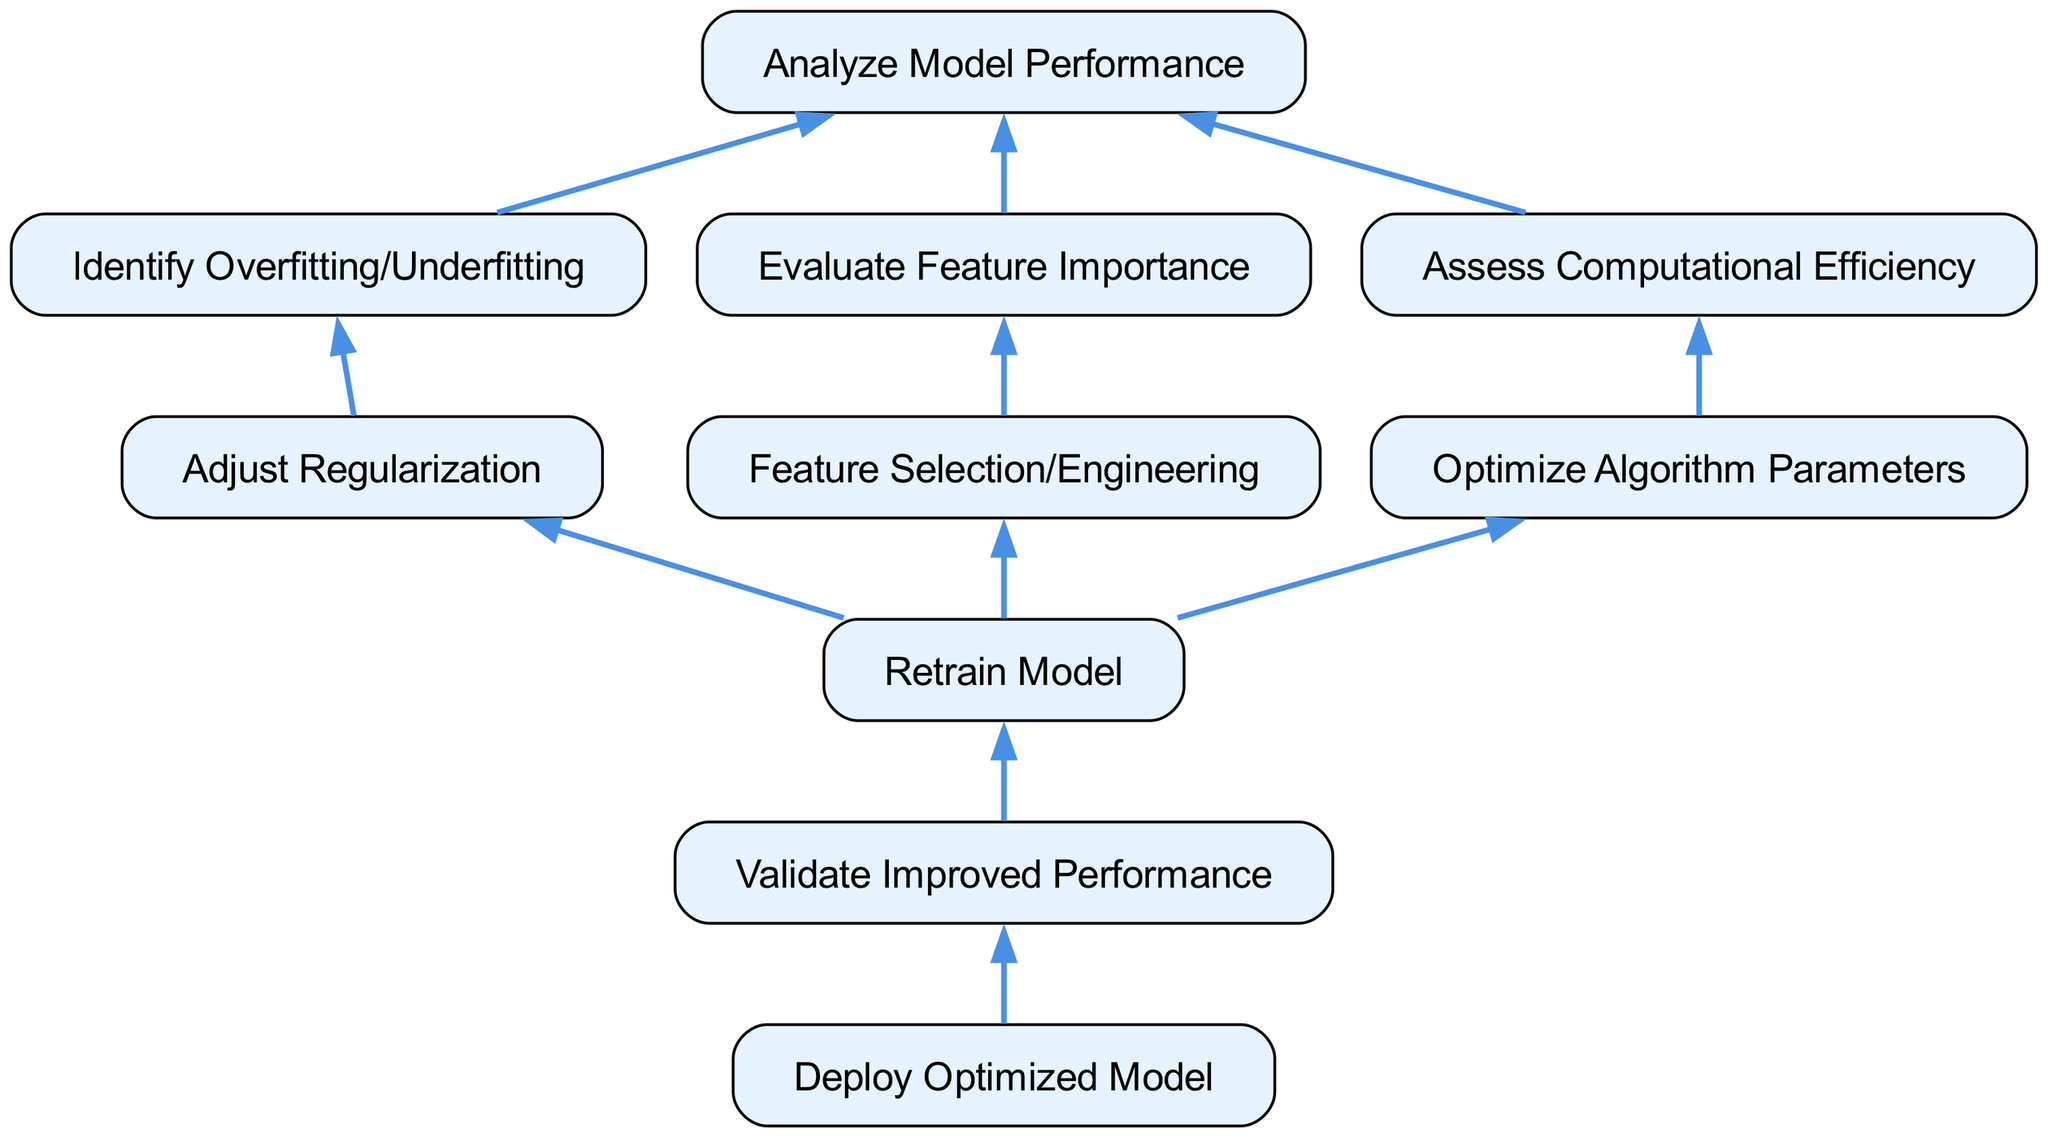What is the final step in the optimization process? The flow chart shows that after "Validate Improved Performance," the next step is "Deploy Optimized Model," which is indicated as the last node.
Answer: Deploy Optimized Model How many main branches are there starting from "Analyze Model Performance"? The diagram indicates three children nodes stemming from "Analyze Model Performance," which are "Identify Overfitting/Underfitting," "Evaluate Feature Importance," and "Assess Computational Efficiency."
Answer: Three What action is taken after "Assess Computational Efficiency"? Following "Assess Computational Efficiency," the flow progresses to "Optimize Algorithm Parameters," which is specifically the next child node for the previous step.
Answer: Optimize Algorithm Parameters Which node leads to "Retrain Model"? The children nodes of "Adjust Regularization," "Feature Selection/Engineering," and "Optimize Algorithm Parameters" all lead into the next step "Retrain Model," as indicated in the diagram's structure.
Answer: Adjust Regularization, Feature Selection/Engineering, Optimize Algorithm Parameters What outcome is expected after "Validate Improved Performance"? The diagram shows that the outcome after "Validate Improved Performance" is "Deploy Optimized Model," which clearly indicates the next step to take upon validation.
Answer: Deploy Optimized Model How does "Identify Overfitting/Underfitting" relate to model adjustment? The node "Identify Overfitting/Underfitting" is directly linked to "Adjust Regularization," indicating that identifying these issues leads to adjustments in model regularization as part of the optimization process.
Answer: Adjust Regularization What role does "Feature Selection/Engineering" play in the process? "Feature Selection/Engineering" is a part of the optimization steps following the importance evaluation of features, leading directly to the "Retrain Model" stage, showing its significant role in modifying features based on their evaluated importance.
Answer: Retrain Model Which step involves assessing efficiency? The step labeled "Assess Computational Efficiency" is identified in the diagram, highlighting the importance of efficiency evaluation in the model optimization process.
Answer: Assess Computational Efficiency How many steps are there from "Analyze Model Performance" to "Deploy Optimized Model"? Counting each node from "Analyze Model Performance" down to "Deploy Optimized Model," there are six steps in total represented in a sequential manner.
Answer: Six 